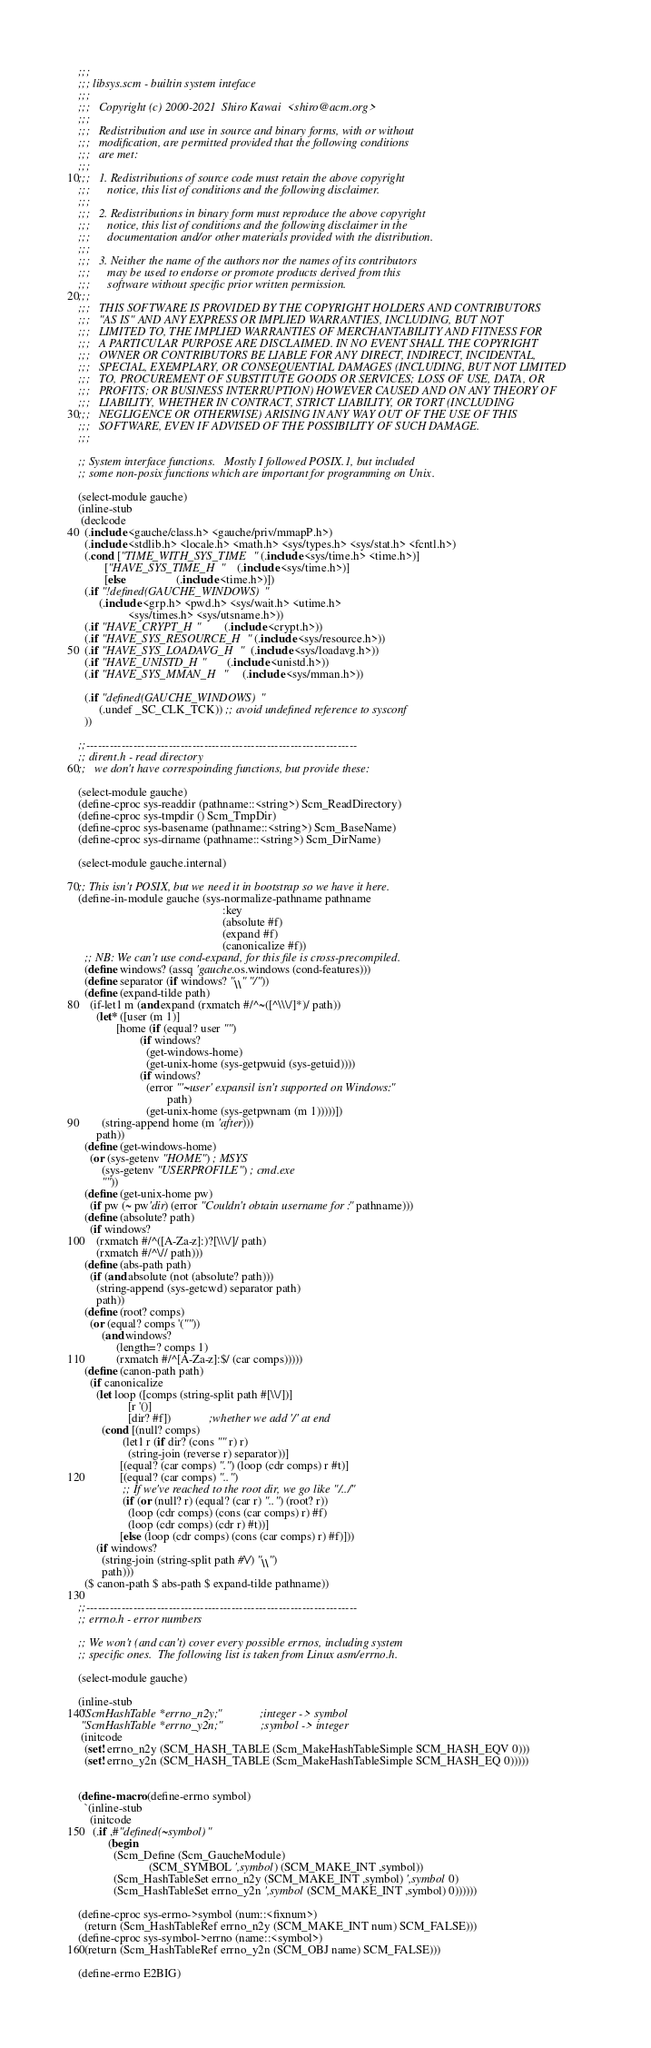<code> <loc_0><loc_0><loc_500><loc_500><_Scheme_>;;;
;;; libsys.scm - builtin system inteface
;;;
;;;   Copyright (c) 2000-2021  Shiro Kawai  <shiro@acm.org>
;;;
;;;   Redistribution and use in source and binary forms, with or without
;;;   modification, are permitted provided that the following conditions
;;;   are met:
;;;
;;;   1. Redistributions of source code must retain the above copyright
;;;      notice, this list of conditions and the following disclaimer.
;;;
;;;   2. Redistributions in binary form must reproduce the above copyright
;;;      notice, this list of conditions and the following disclaimer in the
;;;      documentation and/or other materials provided with the distribution.
;;;
;;;   3. Neither the name of the authors nor the names of its contributors
;;;      may be used to endorse or promote products derived from this
;;;      software without specific prior written permission.
;;;
;;;   THIS SOFTWARE IS PROVIDED BY THE COPYRIGHT HOLDERS AND CONTRIBUTORS
;;;   "AS IS" AND ANY EXPRESS OR IMPLIED WARRANTIES, INCLUDING, BUT NOT
;;;   LIMITED TO, THE IMPLIED WARRANTIES OF MERCHANTABILITY AND FITNESS FOR
;;;   A PARTICULAR PURPOSE ARE DISCLAIMED. IN NO EVENT SHALL THE COPYRIGHT
;;;   OWNER OR CONTRIBUTORS BE LIABLE FOR ANY DIRECT, INDIRECT, INCIDENTAL,
;;;   SPECIAL, EXEMPLARY, OR CONSEQUENTIAL DAMAGES (INCLUDING, BUT NOT LIMITED
;;;   TO, PROCUREMENT OF SUBSTITUTE GOODS OR SERVICES; LOSS OF USE, DATA, OR
;;;   PROFITS; OR BUSINESS INTERRUPTION) HOWEVER CAUSED AND ON ANY THEORY OF
;;;   LIABILITY, WHETHER IN CONTRACT, STRICT LIABILITY, OR TORT (INCLUDING
;;;   NEGLIGENCE OR OTHERWISE) ARISING IN ANY WAY OUT OF THE USE OF THIS
;;;   SOFTWARE, EVEN IF ADVISED OF THE POSSIBILITY OF SUCH DAMAGE.
;;;

;; System interface functions.   Mostly I followed POSIX.1, but included
;; some non-posix functions which are important for programming on Unix.

(select-module gauche)
(inline-stub
 (declcode
  (.include <gauche/class.h> <gauche/priv/mmapP.h>)
  (.include <stdlib.h> <locale.h> <math.h> <sys/types.h> <sys/stat.h> <fcntl.h>)
  (.cond ["TIME_WITH_SYS_TIME" (.include <sys/time.h> <time.h>)]
         ["HAVE_SYS_TIME_H"    (.include <sys/time.h>)]
         [else                 (.include <time.h>)])
  (.if "!defined(GAUCHE_WINDOWS)"
       (.include <grp.h> <pwd.h> <sys/wait.h> <utime.h>
                 <sys/times.h> <sys/utsname.h>))
  (.if "HAVE_CRYPT_H"        (.include <crypt.h>))
  (.if "HAVE_SYS_RESOURCE_H" (.include <sys/resource.h>))
  (.if "HAVE_SYS_LOADAVG_H"  (.include <sys/loadavg.h>))
  (.if "HAVE_UNISTD_H"       (.include <unistd.h>))
  (.if "HAVE_SYS_MMAN_H"     (.include <sys/mman.h>))

  (.if "defined(GAUCHE_WINDOWS)"
       (.undef _SC_CLK_TCK)) ;; avoid undefined reference to sysconf
  ))

;;---------------------------------------------------------------------
;; dirent.h - read directory
;;   we don't have correspoinding functions, but provide these:

(select-module gauche)
(define-cproc sys-readdir (pathname::<string>) Scm_ReadDirectory)
(define-cproc sys-tmpdir () Scm_TmpDir)
(define-cproc sys-basename (pathname::<string>) Scm_BaseName)
(define-cproc sys-dirname (pathname::<string>) Scm_DirName)

(select-module gauche.internal)

;; This isn't POSIX, but we need it in bootstrap so we have it here.
(define-in-module gauche (sys-normalize-pathname pathname
                                                 :key
                                                 (absolute #f)
                                                 (expand #f)
                                                 (canonicalize #f))
  ;; NB: We can't use cond-expand, for this file is cross-precompiled.
  (define windows? (assq 'gauche.os.windows (cond-features)))
  (define separator (if windows? "\\" "/"))
  (define (expand-tilde path)
    (if-let1 m (and expand (rxmatch #/^~([^\\\/]*)/ path))
      (let* ([user (m 1)]
             [home (if (equal? user "")
                     (if windows?
                       (get-windows-home)
                       (get-unix-home (sys-getpwuid (sys-getuid))))
                     (if windows?
                       (error "'~user' expansil isn't supported on Windows:"
                              path)
                       (get-unix-home (sys-getpwnam (m 1)))))])
        (string-append home (m 'after)))
      path))
  (define (get-windows-home)
    (or (sys-getenv "HOME") ; MSYS
        (sys-getenv "USERPROFILE") ; cmd.exe
        ""))
  (define (get-unix-home pw)
    (if pw (~ pw'dir) (error "Couldn't obtain username for :" pathname)))
  (define (absolute? path)
    (if windows?
      (rxmatch #/^([A-Za-z]:)?[\\\/]/ path)
      (rxmatch #/^\// path)))
  (define (abs-path path)
    (if (and absolute (not (absolute? path)))
      (string-append (sys-getcwd) separator path)
      path))
  (define (root? comps)
    (or (equal? comps '(""))
        (and windows?
             (length=? comps 1)
             (rxmatch #/^[A-Za-z]:$/ (car comps)))))
  (define (canon-path path)
    (if canonicalize
      (let loop ([comps (string-split path #[\\/])]
                 [r '()]
                 [dir? #f])             ;whether we add '/' at end
        (cond [(null? comps)
               (let1 r (if dir? (cons "" r) r)
                 (string-join (reverse r) separator))]
              [(equal? (car comps) ".") (loop (cdr comps) r #t)]
              [(equal? (car comps) "..")
               ;; If we've reached to the root dir, we go like "/../"
               (if (or (null? r) (equal? (car r) "..") (root? r))
                 (loop (cdr comps) (cons (car comps) r) #f)
                 (loop (cdr comps) (cdr r) #t))]
              [else (loop (cdr comps) (cons (car comps) r) #f)]))
      (if windows?
        (string-join (string-split path #\/) "\\")
        path)))
  ($ canon-path $ abs-path $ expand-tilde pathname))

;;---------------------------------------------------------------------
;; errno.h - error numbers

;; We won't (and can't) cover every possible errnos, including system
;; specific ones.  The following list is taken from Linux asm/errno.h.

(select-module gauche)

(inline-stub
 "ScmHashTable *errno_n2y;"             ;integer -> symbol
 "ScmHashTable *errno_y2n;"             ;symbol -> integer
 (initcode
  (set! errno_n2y (SCM_HASH_TABLE (Scm_MakeHashTableSimple SCM_HASH_EQV 0)))
  (set! errno_y2n (SCM_HASH_TABLE (Scm_MakeHashTableSimple SCM_HASH_EQ 0)))))


(define-macro (define-errno symbol)
  `(inline-stub
    (initcode
     (.if ,#"defined(~symbol)"
          (begin
            (Scm_Define (Scm_GaucheModule)
                        (SCM_SYMBOL ',symbol) (SCM_MAKE_INT ,symbol))
            (Scm_HashTableSet errno_n2y (SCM_MAKE_INT ,symbol) ',symbol 0)
            (Scm_HashTableSet errno_y2n ',symbol (SCM_MAKE_INT ,symbol) 0))))))

(define-cproc sys-errno->symbol (num::<fixnum>)
  (return (Scm_HashTableRef errno_n2y (SCM_MAKE_INT num) SCM_FALSE)))
(define-cproc sys-symbol->errno (name::<symbol>)
  (return (Scm_HashTableRef errno_y2n (SCM_OBJ name) SCM_FALSE)))

(define-errno E2BIG)</code> 